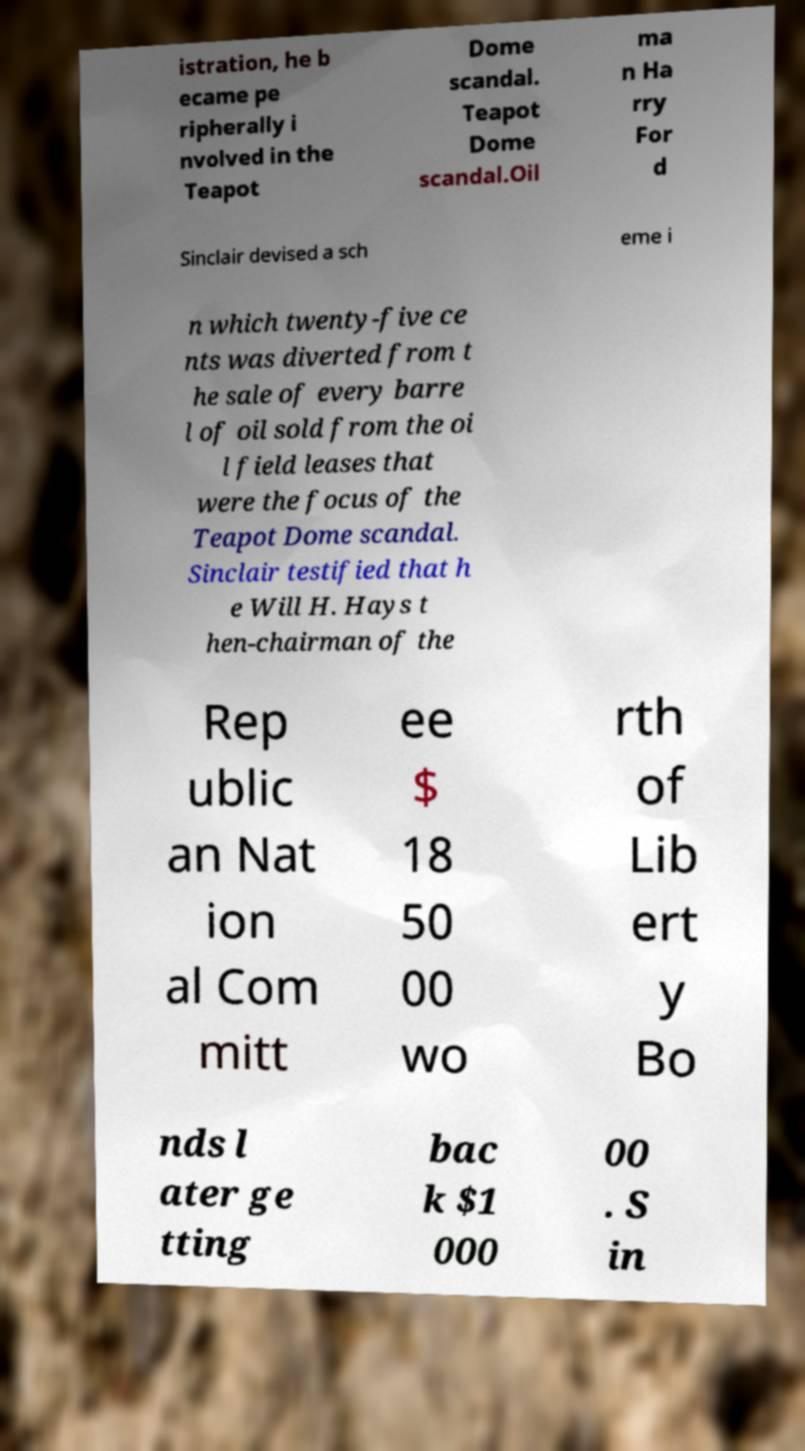Can you accurately transcribe the text from the provided image for me? istration, he b ecame pe ripherally i nvolved in the Teapot Dome scandal. Teapot Dome scandal.Oil ma n Ha rry For d Sinclair devised a sch eme i n which twenty-five ce nts was diverted from t he sale of every barre l of oil sold from the oi l field leases that were the focus of the Teapot Dome scandal. Sinclair testified that h e Will H. Hays t hen-chairman of the Rep ublic an Nat ion al Com mitt ee $ 18 50 00 wo rth of Lib ert y Bo nds l ater ge tting bac k $1 000 00 . S in 